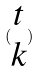Convert formula to latex. <formula><loc_0><loc_0><loc_500><loc_500>( \begin{matrix} t \\ k \end{matrix} )</formula> 